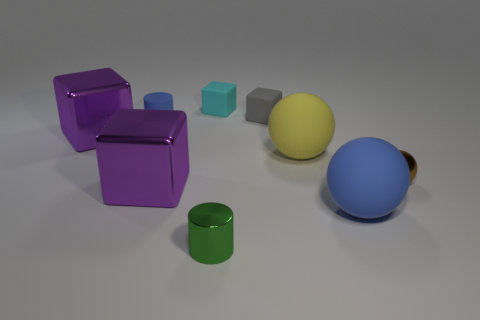Does the purple shiny thing left of the blue cylinder have the same shape as the small object behind the tiny gray rubber object?
Your answer should be very brief. Yes. Is there anything else that has the same material as the big yellow sphere?
Make the answer very short. Yes. What material is the small green cylinder?
Make the answer very short. Metal. There is a cylinder that is in front of the yellow object; what is its material?
Your answer should be compact. Metal. Is there any other thing of the same color as the tiny rubber cylinder?
Provide a short and direct response. Yes. What size is the gray thing that is the same material as the yellow thing?
Offer a very short reply. Small. How many big objects are either red matte cylinders or gray rubber things?
Provide a succinct answer. 0. There is a purple cube that is in front of the large purple metallic object behind the ball that is on the left side of the large blue matte sphere; what is its size?
Offer a terse response. Large. How many green objects have the same size as the blue ball?
Your answer should be very brief. 0. What number of things are either cyan matte cubes or rubber things that are on the right side of the blue rubber cylinder?
Your response must be concise. 4. 